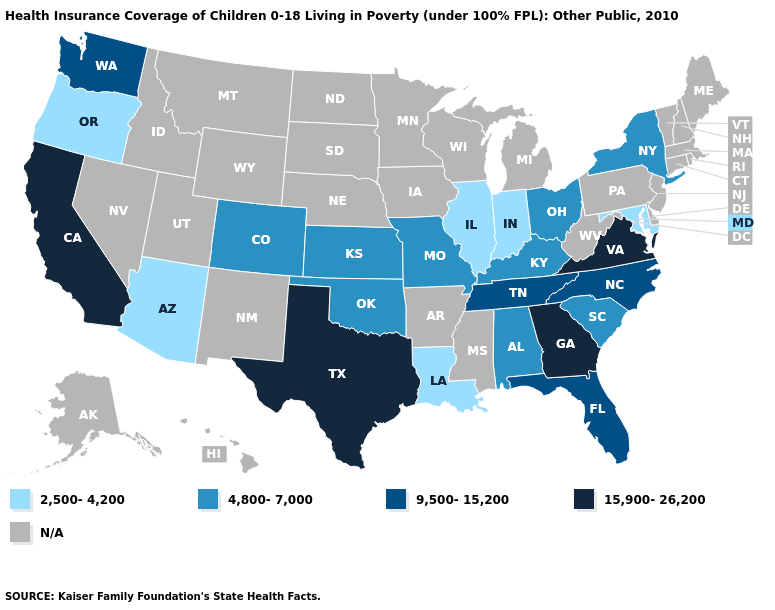What is the lowest value in the USA?
Give a very brief answer. 2,500-4,200. Which states have the lowest value in the MidWest?
Short answer required. Illinois, Indiana. What is the value of South Carolina?
Short answer required. 4,800-7,000. Name the states that have a value in the range 15,900-26,200?
Give a very brief answer. California, Georgia, Texas, Virginia. What is the value of Texas?
Write a very short answer. 15,900-26,200. What is the lowest value in the USA?
Write a very short answer. 2,500-4,200. What is the lowest value in states that border Kansas?
Give a very brief answer. 4,800-7,000. What is the value of Michigan?
Short answer required. N/A. What is the value of Georgia?
Quick response, please. 15,900-26,200. Name the states that have a value in the range 4,800-7,000?
Quick response, please. Alabama, Colorado, Kansas, Kentucky, Missouri, New York, Ohio, Oklahoma, South Carolina. Among the states that border Colorado , which have the lowest value?
Answer briefly. Arizona. Name the states that have a value in the range 15,900-26,200?
Keep it brief. California, Georgia, Texas, Virginia. What is the lowest value in the South?
Answer briefly. 2,500-4,200. Does the first symbol in the legend represent the smallest category?
Keep it brief. Yes. What is the highest value in states that border Massachusetts?
Short answer required. 4,800-7,000. 